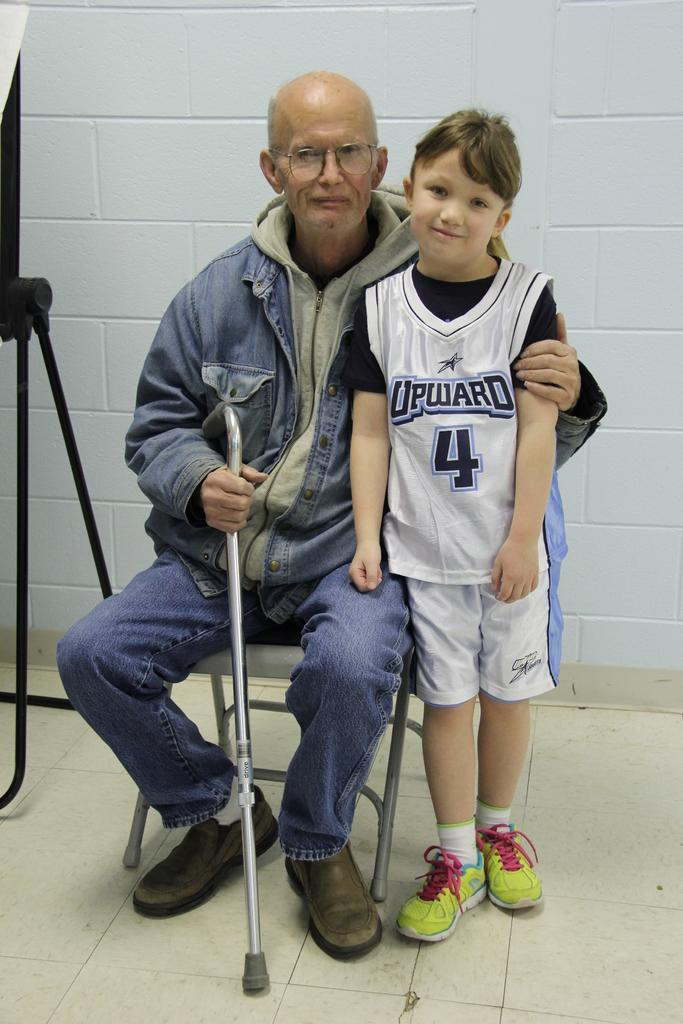<image>
Describe the image concisely. A man with a cane is posting with a young child wearing a jersey that says Upward 4. 